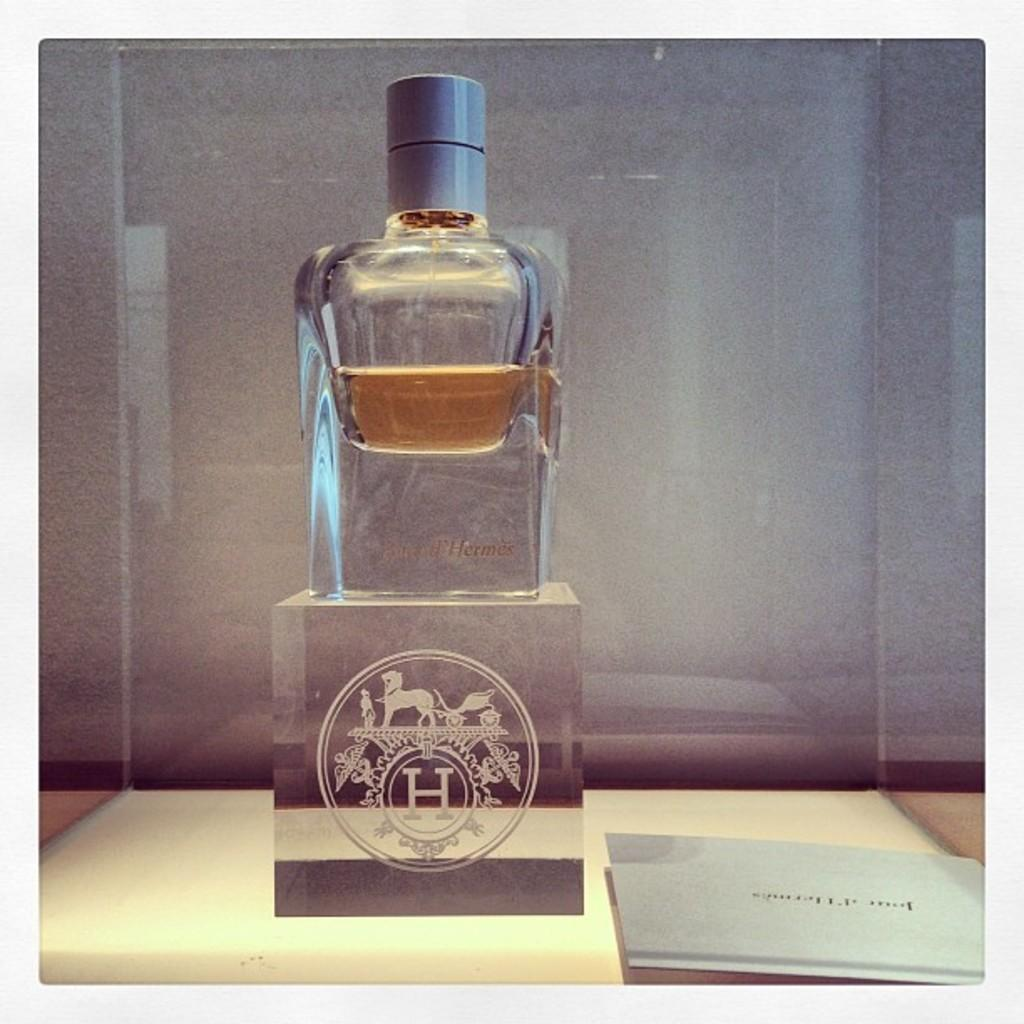<image>
Offer a succinct explanation of the picture presented. A bottle sits on a clear cube that has the letter H on it. 